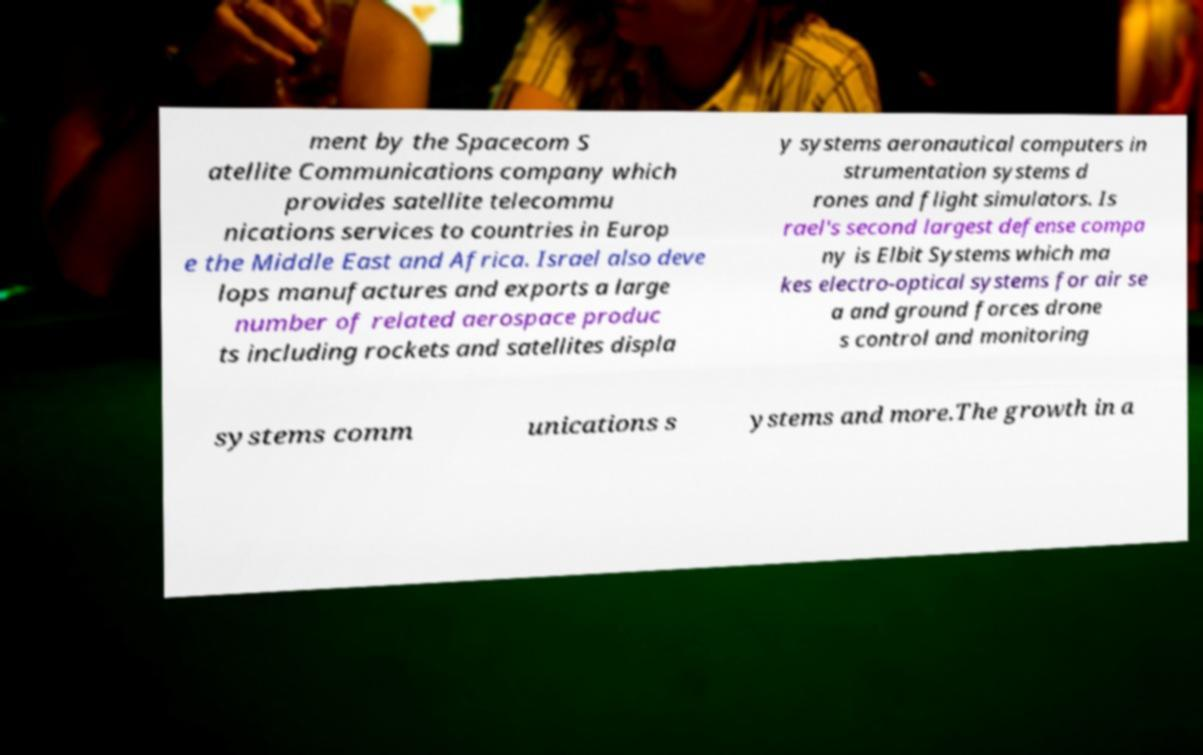Please read and relay the text visible in this image. What does it say? ment by the Spacecom S atellite Communications company which provides satellite telecommu nications services to countries in Europ e the Middle East and Africa. Israel also deve lops manufactures and exports a large number of related aerospace produc ts including rockets and satellites displa y systems aeronautical computers in strumentation systems d rones and flight simulators. Is rael's second largest defense compa ny is Elbit Systems which ma kes electro-optical systems for air se a and ground forces drone s control and monitoring systems comm unications s ystems and more.The growth in a 